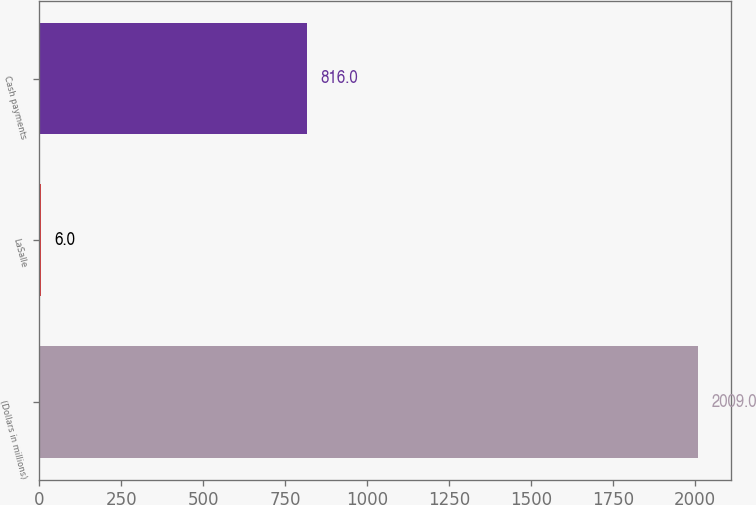Convert chart to OTSL. <chart><loc_0><loc_0><loc_500><loc_500><bar_chart><fcel>(Dollars in millions)<fcel>LaSalle<fcel>Cash payments<nl><fcel>2009<fcel>6<fcel>816<nl></chart> 